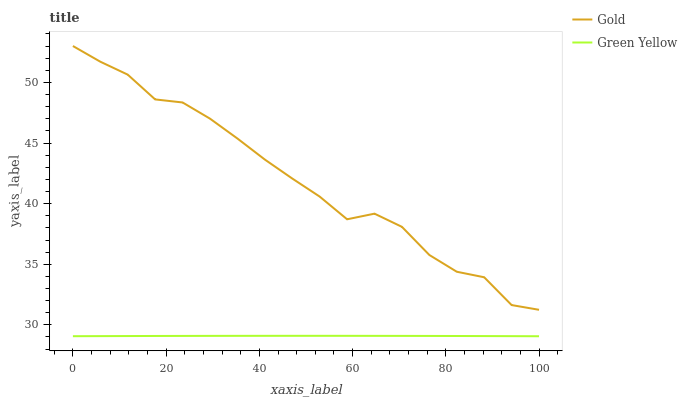Does Green Yellow have the minimum area under the curve?
Answer yes or no. Yes. Does Gold have the maximum area under the curve?
Answer yes or no. Yes. Does Gold have the minimum area under the curve?
Answer yes or no. No. Is Green Yellow the smoothest?
Answer yes or no. Yes. Is Gold the roughest?
Answer yes or no. Yes. Is Gold the smoothest?
Answer yes or no. No. Does Green Yellow have the lowest value?
Answer yes or no. Yes. Does Gold have the lowest value?
Answer yes or no. No. Does Gold have the highest value?
Answer yes or no. Yes. Is Green Yellow less than Gold?
Answer yes or no. Yes. Is Gold greater than Green Yellow?
Answer yes or no. Yes. Does Green Yellow intersect Gold?
Answer yes or no. No. 